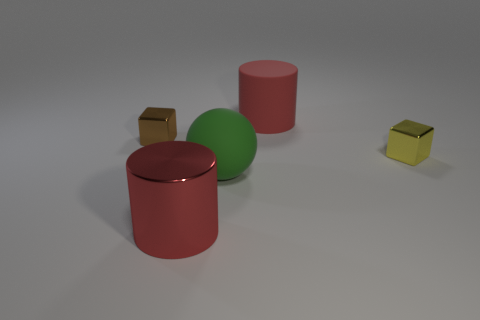Is the material of the block right of the big green object the same as the brown block?
Keep it short and to the point. Yes. How many other objects are the same material as the large green thing?
Offer a terse response. 1. What number of things are red things that are to the right of the big green matte object or blocks in front of the brown metallic cube?
Your answer should be compact. 2. There is a tiny metallic thing that is on the right side of the small brown metal thing; is it the same shape as the small thing on the left side of the red shiny cylinder?
Keep it short and to the point. Yes. There is a object that is the same size as the brown metal block; what shape is it?
Give a very brief answer. Cube. What number of metal things are tiny objects or gray cylinders?
Offer a very short reply. 2. Are the red cylinder that is in front of the green object and the tiny thing that is to the right of the big green ball made of the same material?
Give a very brief answer. Yes. There is another big thing that is made of the same material as the large green thing; what is its color?
Your answer should be very brief. Red. Are there more large red cylinders that are in front of the ball than green matte spheres that are left of the large red shiny cylinder?
Provide a succinct answer. Yes. Are any large purple shiny cubes visible?
Make the answer very short. No. 